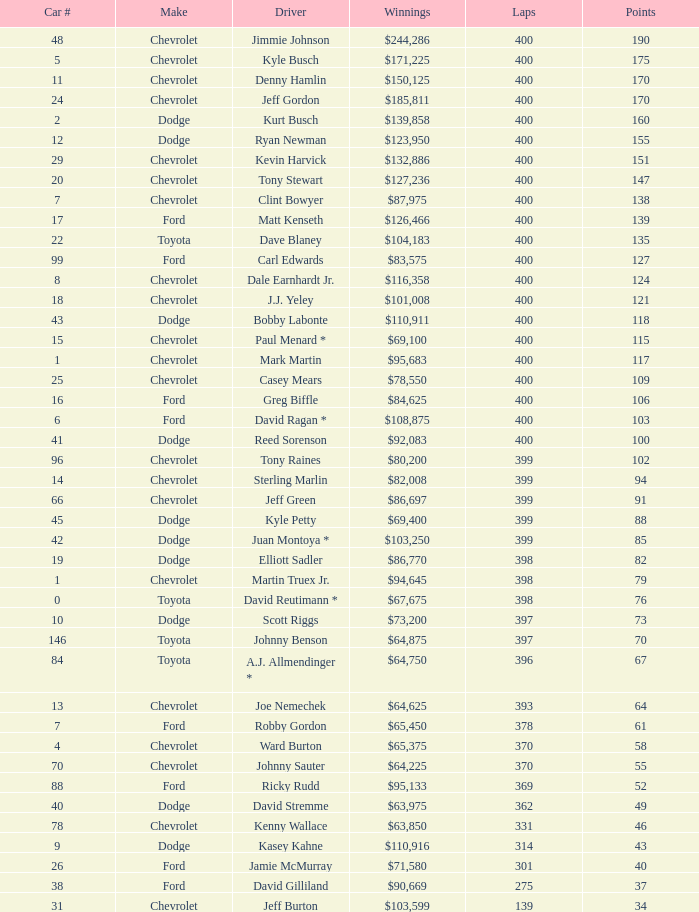What is the car number that has less than 369 laps for a Dodge with more than 49 points? None. 